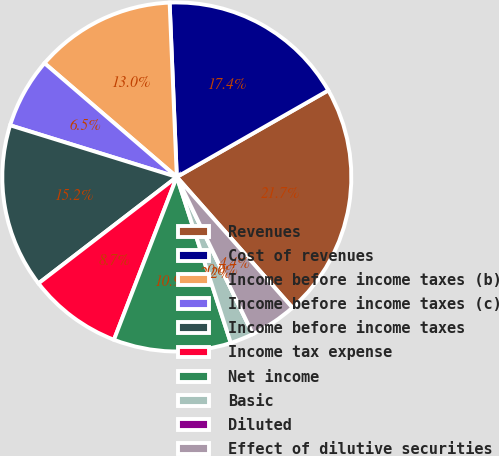Convert chart. <chart><loc_0><loc_0><loc_500><loc_500><pie_chart><fcel>Revenues<fcel>Cost of revenues<fcel>Income before income taxes (b)<fcel>Income before income taxes (c)<fcel>Income before income taxes<fcel>Income tax expense<fcel>Net income<fcel>Basic<fcel>Diluted<fcel>Effect of dilutive securities<nl><fcel>21.74%<fcel>17.39%<fcel>13.04%<fcel>6.52%<fcel>15.22%<fcel>8.7%<fcel>10.87%<fcel>2.17%<fcel>0.0%<fcel>4.35%<nl></chart> 